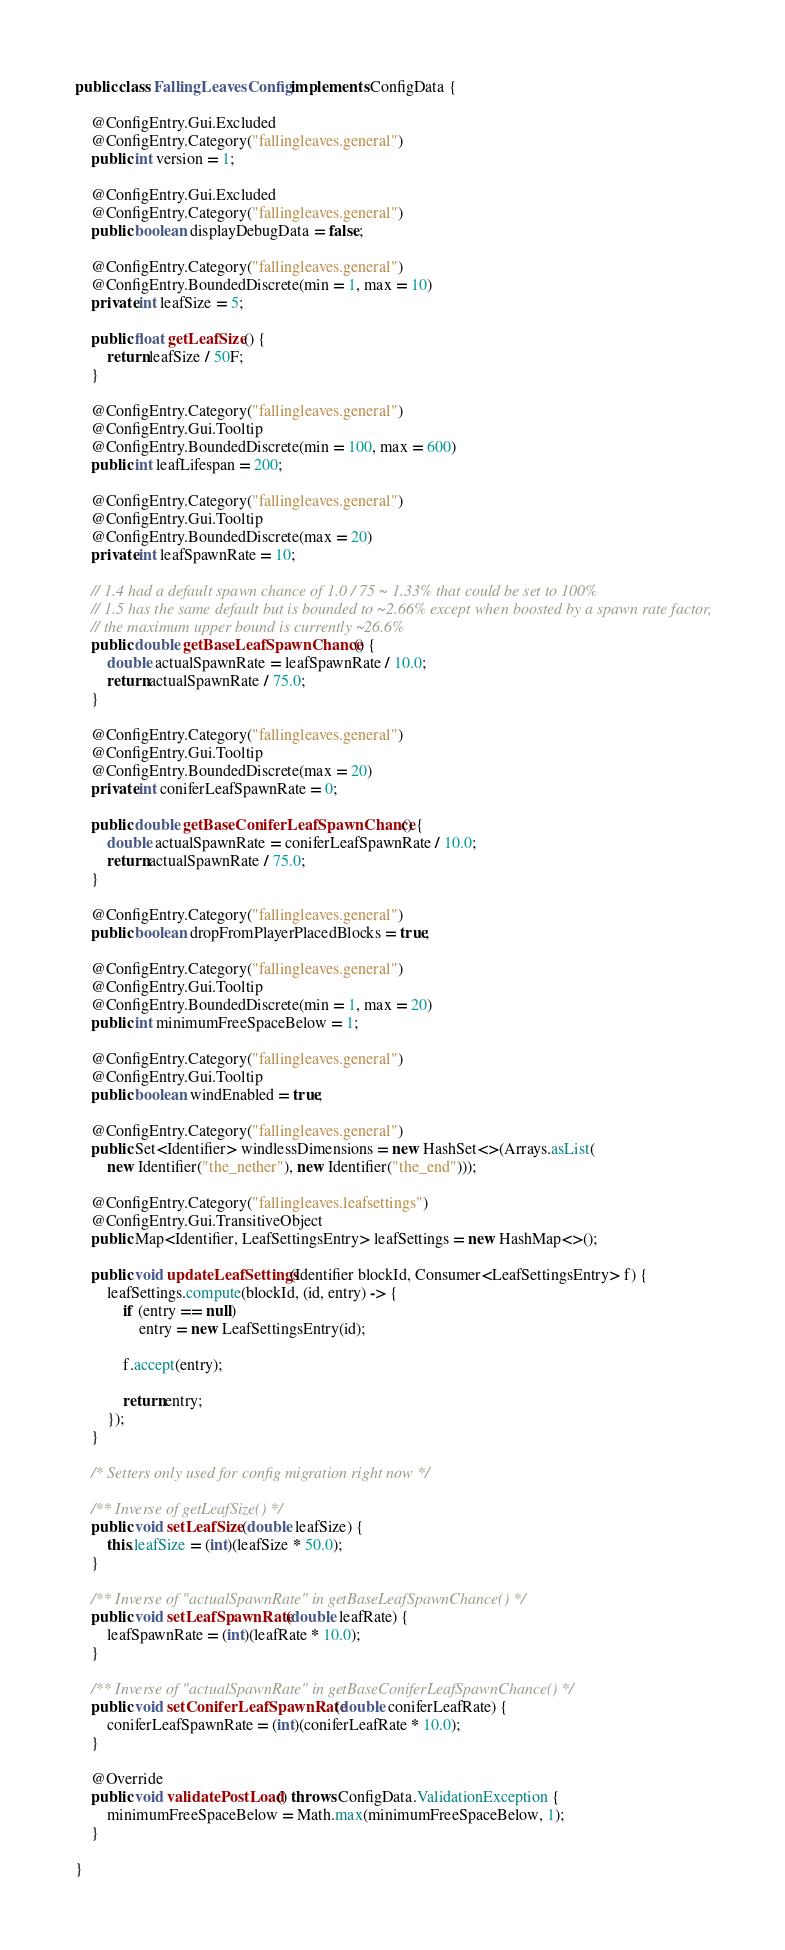<code> <loc_0><loc_0><loc_500><loc_500><_Java_>public class FallingLeavesConfig implements ConfigData {

    @ConfigEntry.Gui.Excluded
    @ConfigEntry.Category("fallingleaves.general")
    public int version = 1;

    @ConfigEntry.Gui.Excluded
    @ConfigEntry.Category("fallingleaves.general")
    public boolean displayDebugData = false;

    @ConfigEntry.Category("fallingleaves.general")
    @ConfigEntry.BoundedDiscrete(min = 1, max = 10)
    private int leafSize = 5;

    public float getLeafSize() {
        return leafSize / 50F;
    }

    @ConfigEntry.Category("fallingleaves.general")
    @ConfigEntry.Gui.Tooltip
    @ConfigEntry.BoundedDiscrete(min = 100, max = 600)
    public int leafLifespan = 200;

    @ConfigEntry.Category("fallingleaves.general")
    @ConfigEntry.Gui.Tooltip
    @ConfigEntry.BoundedDiscrete(max = 20)
    private int leafSpawnRate = 10;

    // 1.4 had a default spawn chance of 1.0 / 75 ~ 1.33% that could be set to 100%
    // 1.5 has the same default but is bounded to ~2.66% except when boosted by a spawn rate factor,
    // the maximum upper bound is currently ~26.6%
    public double getBaseLeafSpawnChance() {
        double actualSpawnRate = leafSpawnRate / 10.0;
        return actualSpawnRate / 75.0;
    }

    @ConfigEntry.Category("fallingleaves.general")
    @ConfigEntry.Gui.Tooltip
    @ConfigEntry.BoundedDiscrete(max = 20)
    private int coniferLeafSpawnRate = 0;

    public double getBaseConiferLeafSpawnChance() {
        double actualSpawnRate = coniferLeafSpawnRate / 10.0;
        return actualSpawnRate / 75.0;
    }

    @ConfigEntry.Category("fallingleaves.general")
    public boolean dropFromPlayerPlacedBlocks = true;

    @ConfigEntry.Category("fallingleaves.general")
    @ConfigEntry.Gui.Tooltip
    @ConfigEntry.BoundedDiscrete(min = 1, max = 20)
    public int minimumFreeSpaceBelow = 1;

    @ConfigEntry.Category("fallingleaves.general")
    @ConfigEntry.Gui.Tooltip
    public boolean windEnabled = true;

    @ConfigEntry.Category("fallingleaves.general")
    public Set<Identifier> windlessDimensions = new HashSet<>(Arrays.asList(
        new Identifier("the_nether"), new Identifier("the_end")));

    @ConfigEntry.Category("fallingleaves.leafsettings")
    @ConfigEntry.Gui.TransitiveObject
    public Map<Identifier, LeafSettingsEntry> leafSettings = new HashMap<>();

    public void updateLeafSettings(Identifier blockId, Consumer<LeafSettingsEntry> f) {
        leafSettings.compute(blockId, (id, entry) -> {
            if (entry == null)
                entry = new LeafSettingsEntry(id);

            f.accept(entry);

            return entry;
        });
    }

    /* Setters only used for config migration right now */

    /** Inverse of getLeafSize() */
    public void setLeafSize(double leafSize) {
        this.leafSize = (int)(leafSize * 50.0);
    }

    /** Inverse of "actualSpawnRate" in getBaseLeafSpawnChance() */
    public void setLeafSpawnRate(double leafRate) {
        leafSpawnRate = (int)(leafRate * 10.0);
    }

    /** Inverse of "actualSpawnRate" in getBaseConiferLeafSpawnChance() */
    public void setConiferLeafSpawnRate(double coniferLeafRate) {
        coniferLeafSpawnRate = (int)(coniferLeafRate * 10.0);
    }

    @Override
    public void validatePostLoad() throws ConfigData.ValidationException {
        minimumFreeSpaceBelow = Math.max(minimumFreeSpaceBelow, 1);
    }

}</code> 